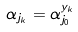<formula> <loc_0><loc_0><loc_500><loc_500>\alpha _ { j _ { k } } = \alpha _ { j _ { 0 } } ^ { y _ { k } }</formula> 